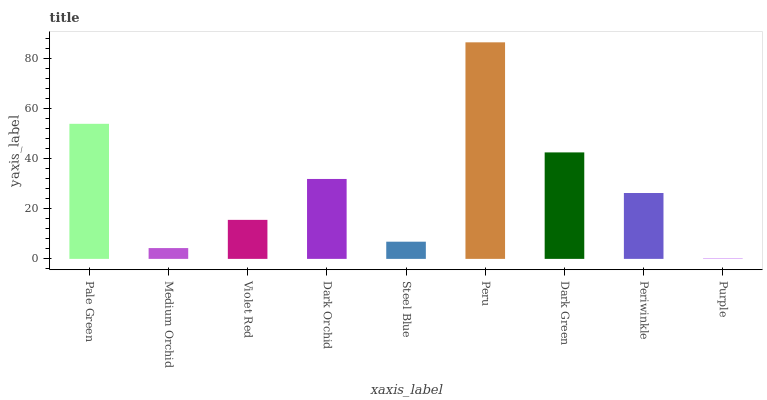Is Purple the minimum?
Answer yes or no. Yes. Is Peru the maximum?
Answer yes or no. Yes. Is Medium Orchid the minimum?
Answer yes or no. No. Is Medium Orchid the maximum?
Answer yes or no. No. Is Pale Green greater than Medium Orchid?
Answer yes or no. Yes. Is Medium Orchid less than Pale Green?
Answer yes or no. Yes. Is Medium Orchid greater than Pale Green?
Answer yes or no. No. Is Pale Green less than Medium Orchid?
Answer yes or no. No. Is Periwinkle the high median?
Answer yes or no. Yes. Is Periwinkle the low median?
Answer yes or no. Yes. Is Pale Green the high median?
Answer yes or no. No. Is Pale Green the low median?
Answer yes or no. No. 